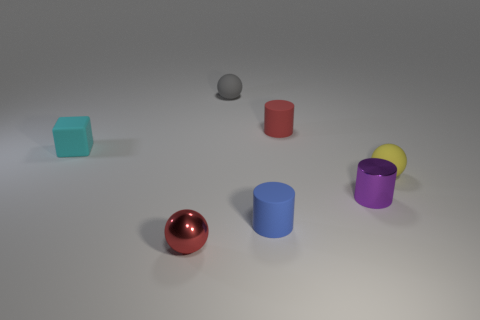There is a shiny object right of the small sphere that is in front of the purple shiny object; what is its color? The shiny object to the right of the small sphere, which is located in front of the purple object, has a glossy red appearance. 